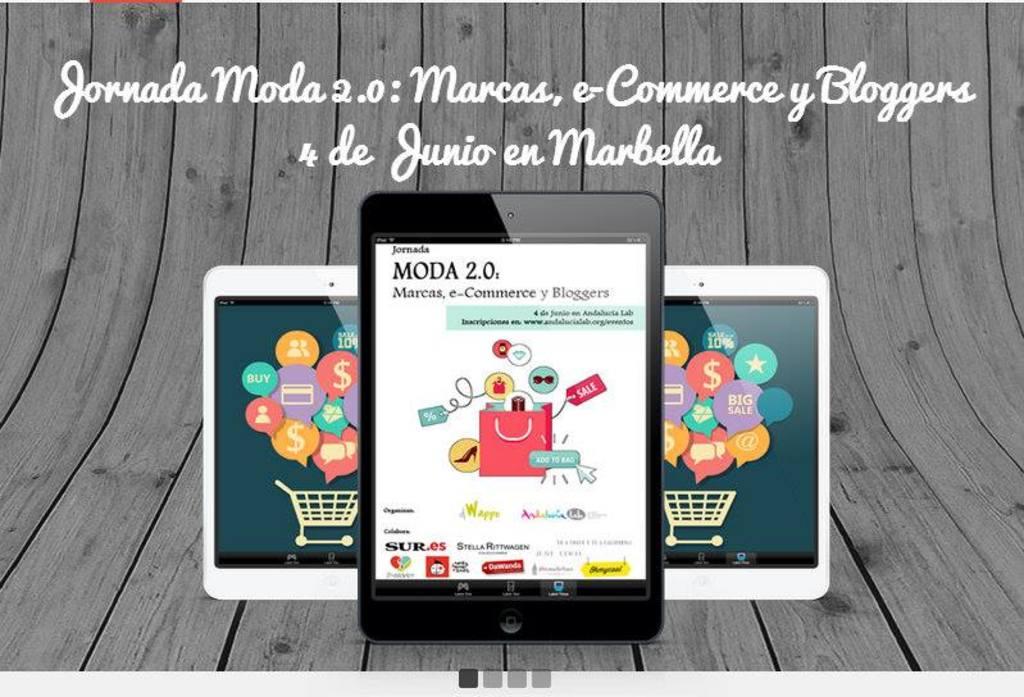What version of the app is this?
Provide a succinct answer. 2.0. 